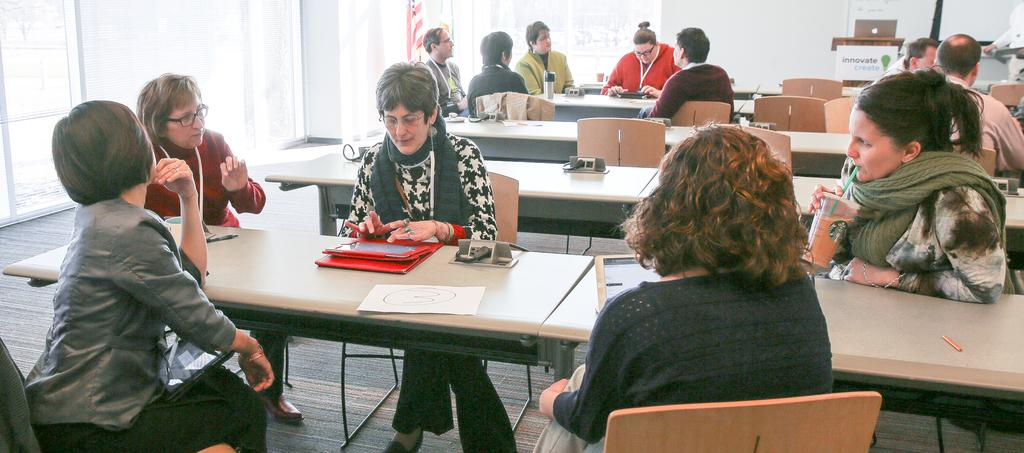What are the people in the image doing? The people in the image are sitting on chairs. What is on the table in the image? There are files, an iPad, and a juice glass on the table. What is the women in the image wearing around their necks? The women in the image are wearing scarves around their necks. What shape does the achiever make when they smash the circle in the image? There is no achiever, circle, or smashing action present in the image. 